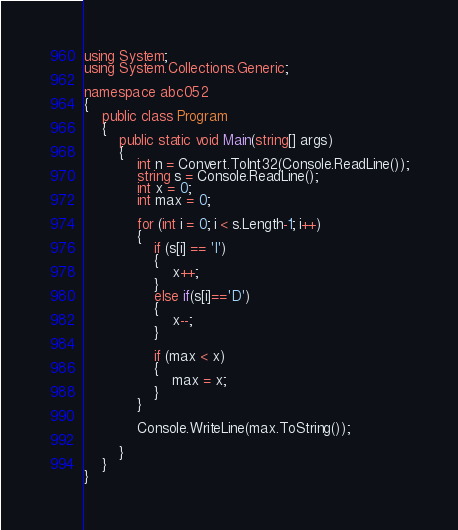<code> <loc_0><loc_0><loc_500><loc_500><_C#_>using System;
using System.Collections.Generic;

namespace abc052
{
    public class Program
    {
        public static void Main(string[] args)
        {
            int n = Convert.ToInt32(Console.ReadLine());
            string s = Console.ReadLine();
            int x = 0;
            int max = 0;

            for (int i = 0; i < s.Length-1; i++)
            {
                if (s[i] == 'I')
                {
                    x++;
                }
                else if(s[i]=='D')
                {
                    x--;
                }

                if (max < x)
                {
                    max = x;
                }
            }

            Console.WriteLine(max.ToString());

        }
    }
}
</code> 